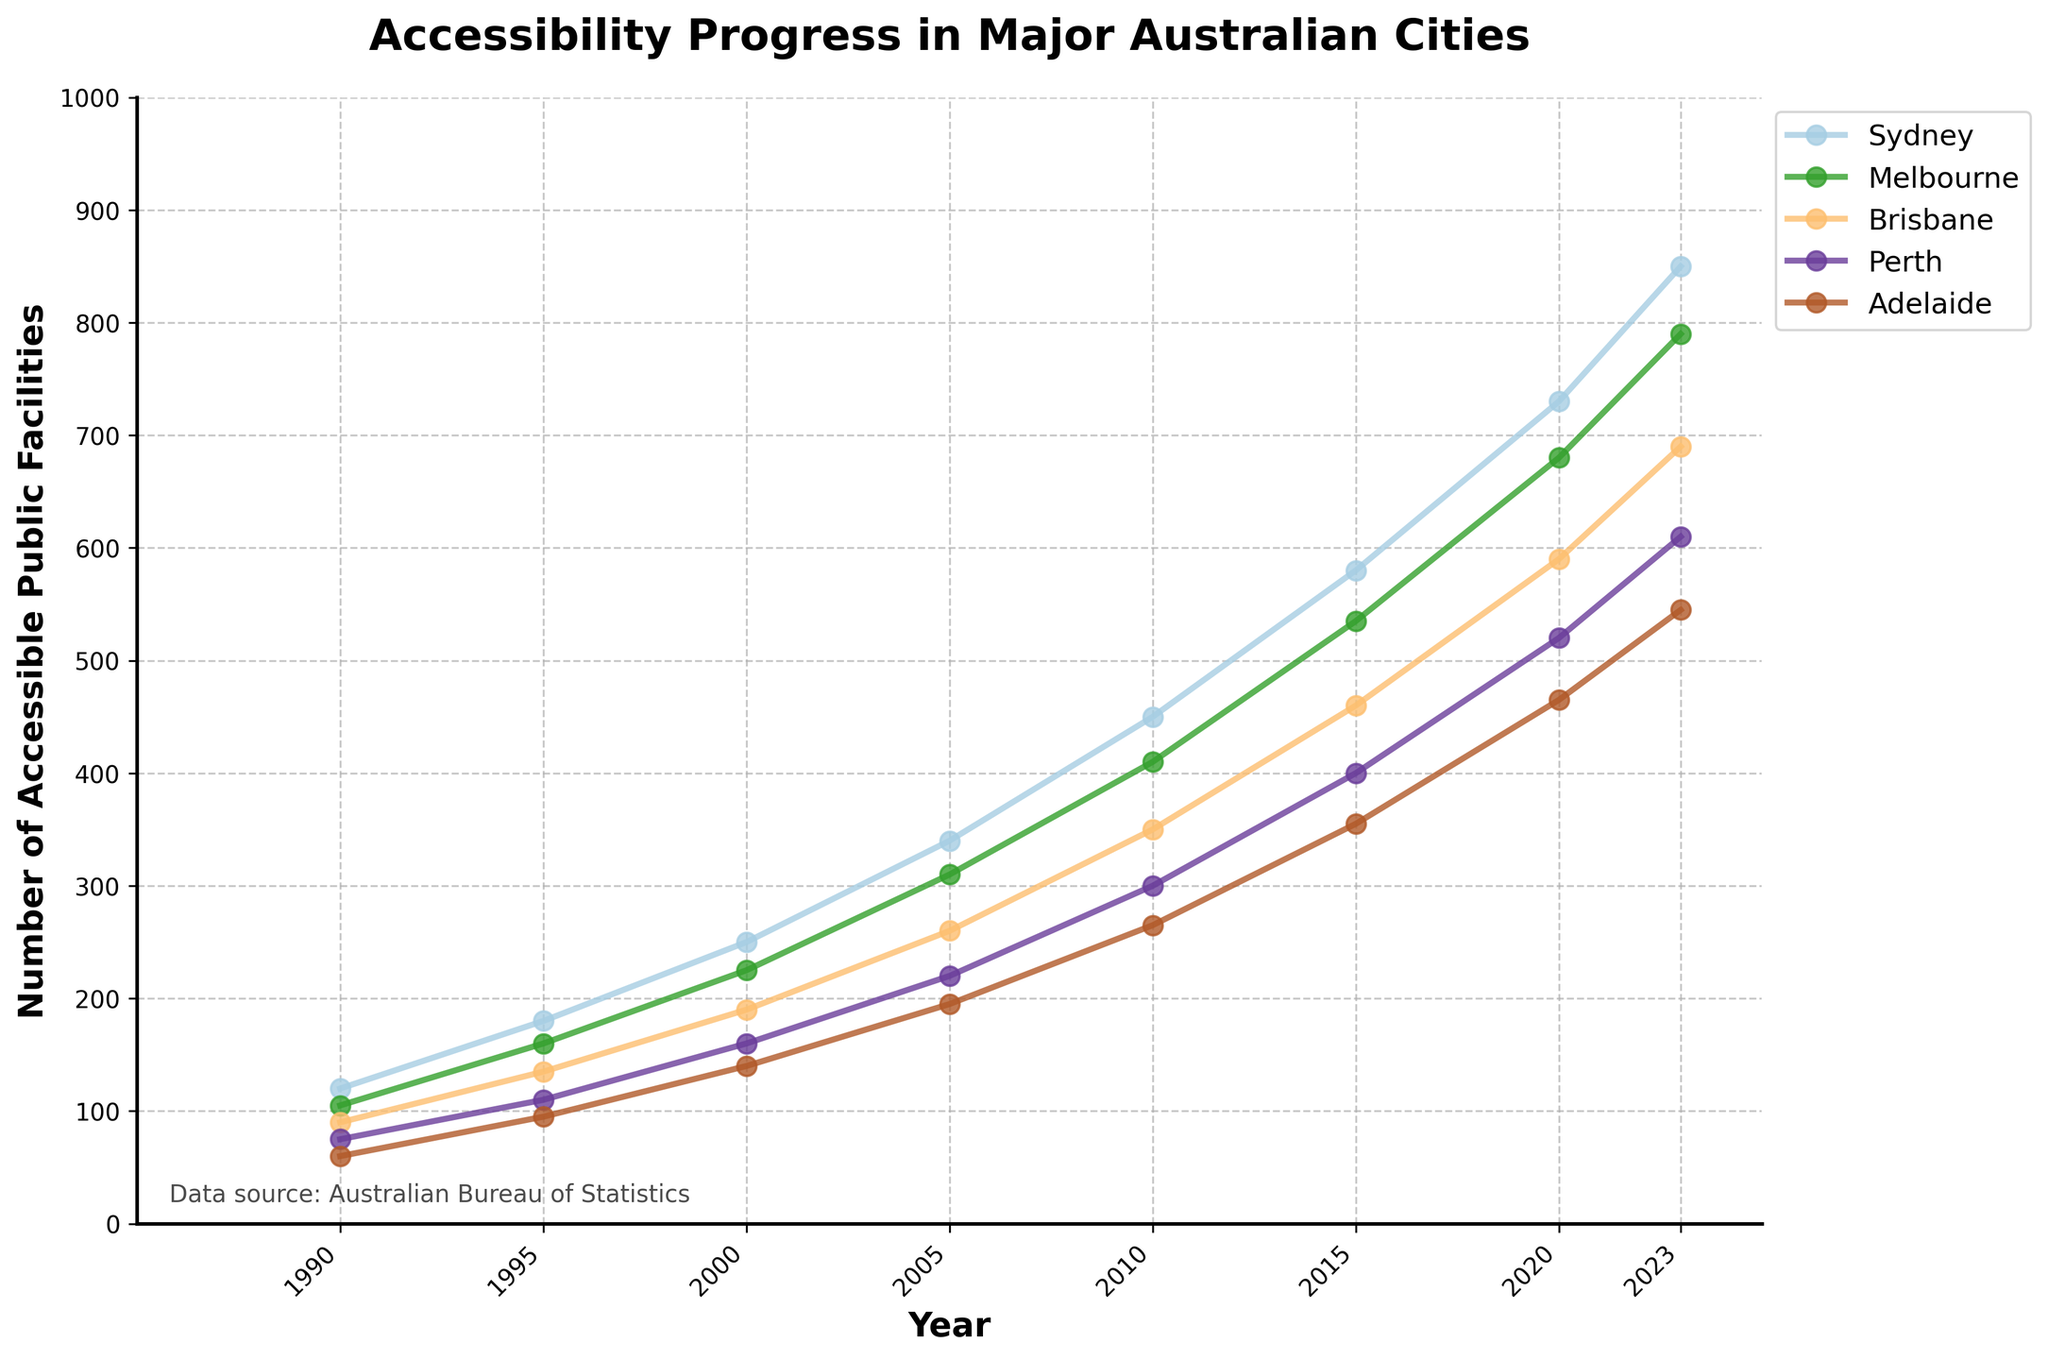Which city had the most accessible public facilities in 2023? By looking at the endpoint of each line on the chart for the year 2023, you can see which line is at the highest position.
Answer: Sydney Which city showed the most significant improvement in the number of accessible public facilities from 1990 to 2023? Calculate the difference between the number of facilities in 2023 and 1990 for each city. Sydney (850-120=730), Melbourne (790-105=685), Brisbane (690-90=600), Perth (610-75=535), and Adelaide (545-60=485). Sydney shows the highest difference.
Answer: Sydney By how much did the number of accessible public facilities in Adelaide increase from 2000 to 2023? Subtract the number of facilities in Adelaide in 2000 (140) from the number in 2023 (545).
Answer: 405 Between which years did Brisbane see the highest growth in the number of accessible public facilities? Examine the slope of Brisbane's line. The steepest rise is from 2015 to 2020.
Answer: 2015 to 2020 What is the average number of accessible public facilities in Perth over the entire period from 1990 to 2023? Sum the number of facilities in Perth for all given years and divide by the number of data points (1990, 1995, 2000, 2005, 2010, 2015, 2020, 2023). (75 + 110 + 160 + 220 + 300 + 400 + 520 + 610)/8 = 299.375
Answer: 299.375 Which two cities had the closest number of accessible public facilities in 2015? Compare the value of facilities for all cities in 2015. Adelaide (355) and Perth (400) have the closest values. The difference is
Answer: 45 What trend do you observe in the accessibility of public facilities in all cities over the period shown in the chart? The lines for all cities are ascending, indicating a continuous increase in the number of accessible public facilities over time.
Answer: Continuous increase Which city had the least number of accessible public facilities in 2000, and how many did it have? Check the values for each city in 2000. Adelaide has the lowest number with 140 facilities.
Answer: Adelaide, 140 Between 2010 and 2015, did any city experience a decline in the number of accessible public facilities? Examine the slopes for each city between 2010 to 2015. All lines are ascending, indicating there were no declines.
Answer: No What is the rate of increase per year in the number of accessible public facilities in Melbourne from 1990 to 2023? The rate of increase can be found by subtracting Melbourne's 1990 value from the 2023 value and then dividing by the number of years (2023-1990 = 33 years). (790-105) / 33 ≈ 20.727 facilities per year
Answer: 20.727 